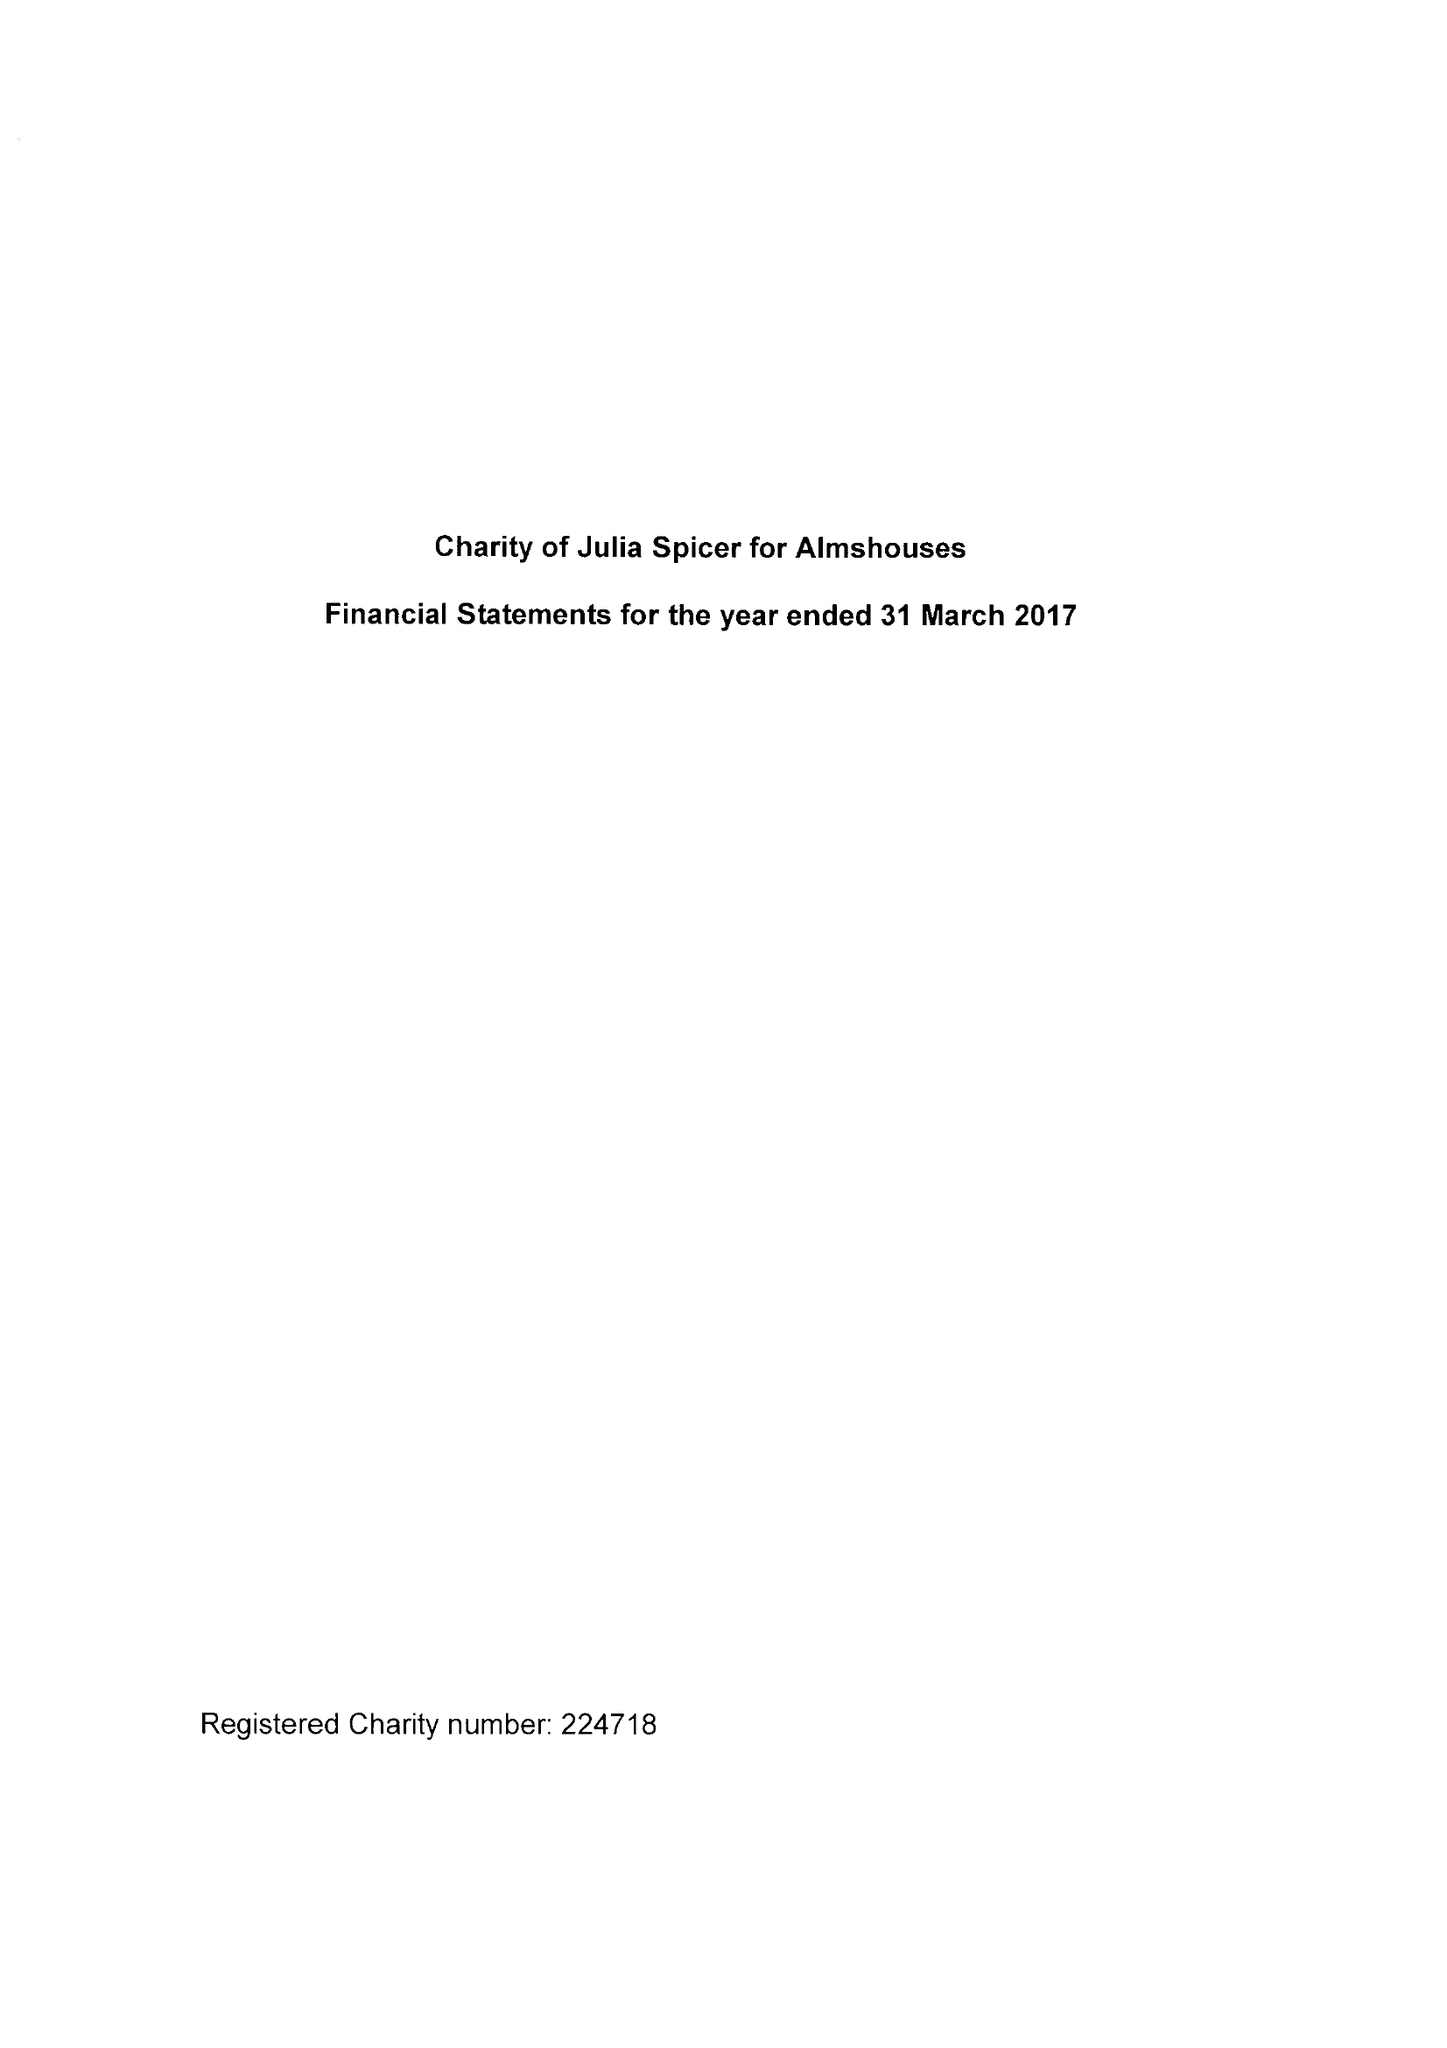What is the value for the income_annually_in_british_pounds?
Answer the question using a single word or phrase. 70196.00 